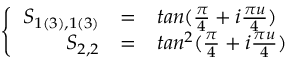Convert formula to latex. <formula><loc_0><loc_0><loc_500><loc_500>\left \{ \begin{array} { r c l } { { S _ { 1 ( 3 ) , 1 ( 3 ) } } } & { = } & { { t a n ( \frac { \pi } { 4 } + i \frac { \pi u } { 4 } ) } } \\ { { S _ { 2 , 2 } } } & { = } & { { t a n ^ { 2 } ( \frac { \pi } { 4 } + i \frac { \pi u } { 4 } ) } } \end{array}</formula> 